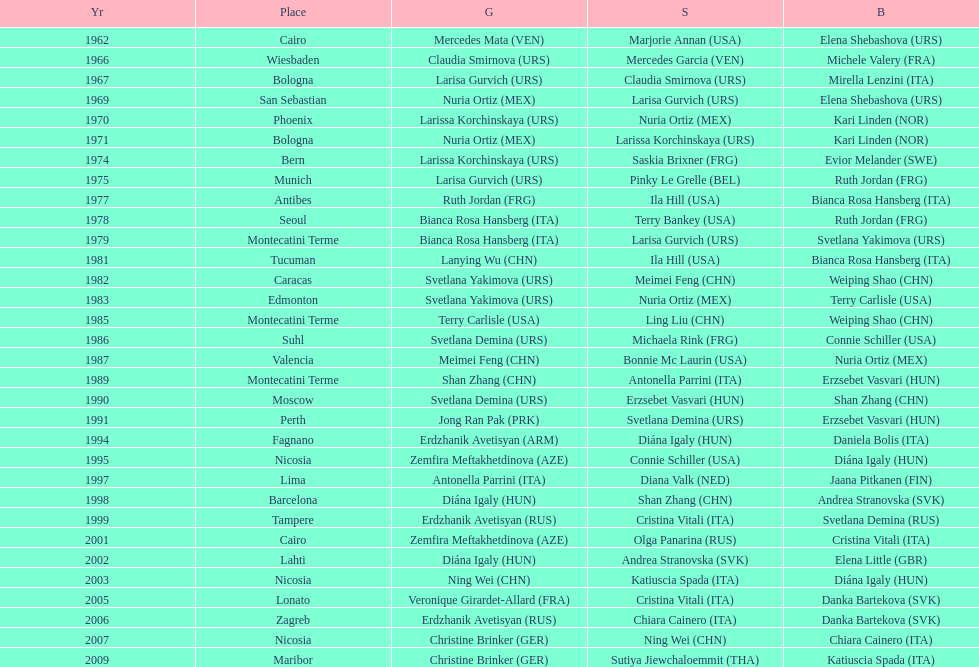Who won the only gold medal in 1962? Mercedes Mata. 